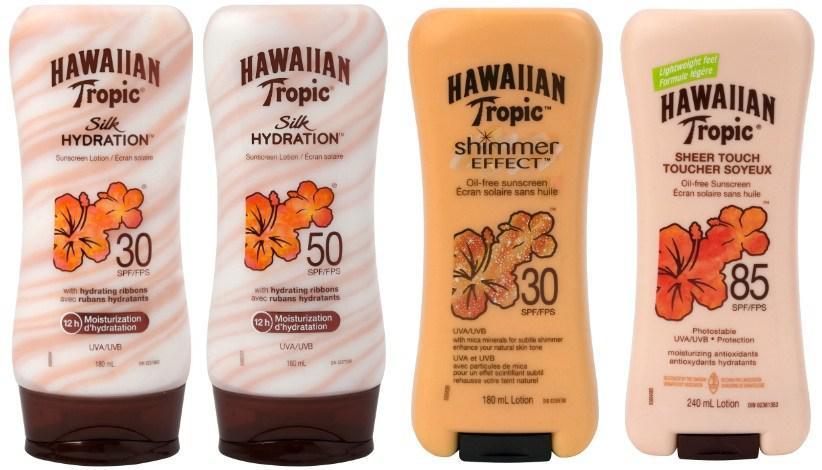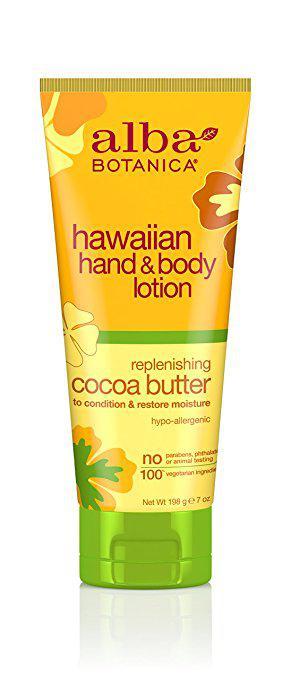The first image is the image on the left, the second image is the image on the right. Examine the images to the left and right. Is the description "An image shows one tube-type skincare product standing upright on its green cap." accurate? Answer yes or no. Yes. 